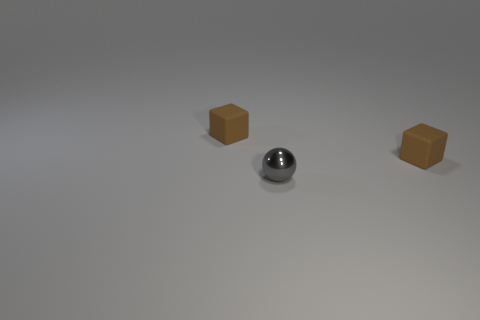How many other things are the same size as the gray metal ball?
Offer a very short reply. 2. How many cubes are tiny brown objects or small gray objects?
Make the answer very short. 2. Is the number of tiny brown cubes that are behind the tiny gray metallic thing greater than the number of tiny shiny spheres?
Make the answer very short. Yes. How many objects are brown blocks that are behind the gray metal ball or small metal spheres?
Offer a terse response. 3. The ball left of the small rubber object that is on the right side of the gray ball is made of what material?
Your response must be concise. Metal. Is there a tiny rubber thing that is right of the small cube that is left of the small gray shiny ball?
Make the answer very short. Yes. There is a small cube that is to the left of the sphere; what is its material?
Offer a very short reply. Rubber. There is a block on the right side of the brown rubber object that is left of the tiny object on the right side of the shiny object; what is its color?
Make the answer very short. Brown. How many other brown objects have the same shape as the metallic object?
Your answer should be very brief. 0. There is a brown matte cube in front of the brown object on the left side of the gray metallic object; what size is it?
Your answer should be compact. Small. 